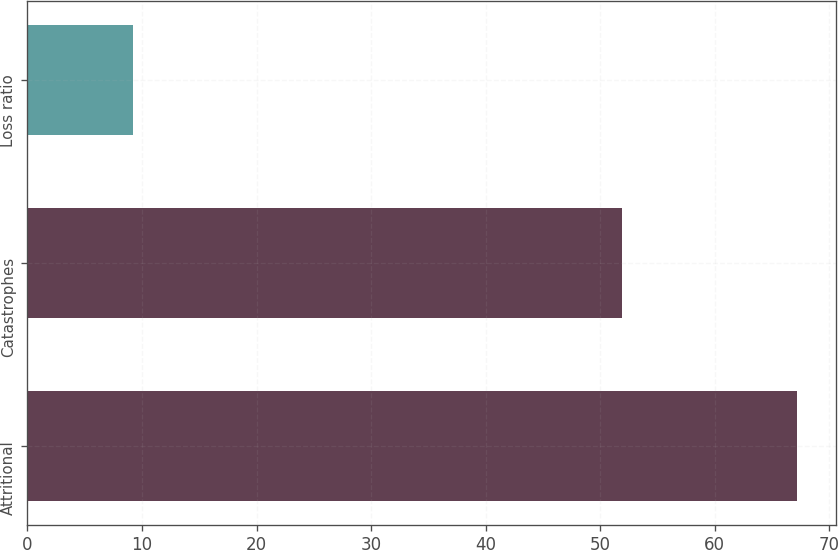Convert chart to OTSL. <chart><loc_0><loc_0><loc_500><loc_500><bar_chart><fcel>Attritional<fcel>Catastrophes<fcel>Loss ratio<nl><fcel>67.2<fcel>51.9<fcel>9.2<nl></chart> 